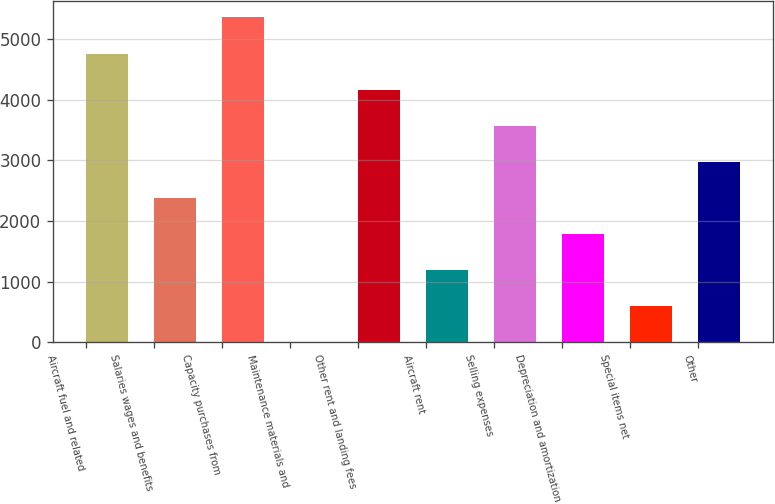<chart> <loc_0><loc_0><loc_500><loc_500><bar_chart><fcel>Aircraft fuel and related<fcel>Salaries wages and benefits<fcel>Capacity purchases from<fcel>Maintenance materials and<fcel>Other rent and landing fees<fcel>Aircraft rent<fcel>Selling expenses<fcel>Depreciation and amortization<fcel>Special items net<fcel>Other<nl><fcel>4762.4<fcel>2383.2<fcel>5357.2<fcel>4<fcel>4167.6<fcel>1193.6<fcel>3572.8<fcel>1788.4<fcel>598.8<fcel>2978<nl></chart> 